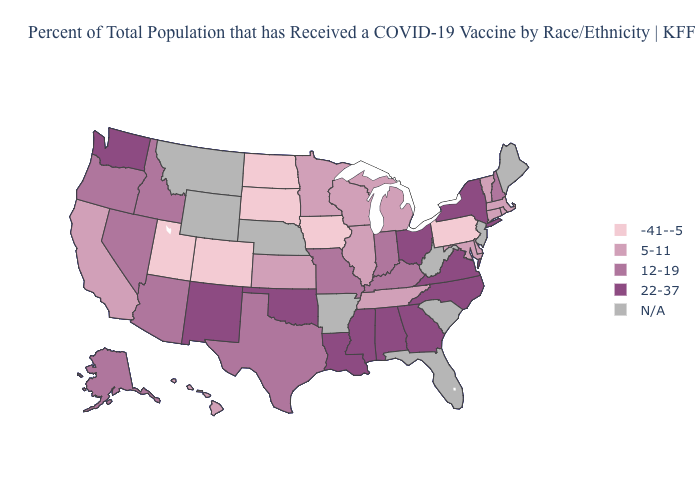Among the states that border New Mexico , which have the lowest value?
Keep it brief. Colorado, Utah. What is the value of Maine?
Answer briefly. N/A. Does New York have the highest value in the Northeast?
Answer briefly. Yes. What is the value of Georgia?
Concise answer only. 22-37. What is the highest value in states that border Indiana?
Answer briefly. 22-37. Which states hav the highest value in the Northeast?
Short answer required. New York. Does Virginia have the highest value in the USA?
Give a very brief answer. Yes. Among the states that border North Carolina , which have the highest value?
Quick response, please. Georgia, Virginia. What is the value of Nevada?
Be succinct. 12-19. What is the value of New Jersey?
Keep it brief. N/A. What is the lowest value in the Northeast?
Quick response, please. -41--5. Name the states that have a value in the range 12-19?
Write a very short answer. Alaska, Arizona, Idaho, Indiana, Kentucky, Missouri, Nevada, New Hampshire, Oregon, Texas. Does Connecticut have the highest value in the USA?
Keep it brief. No. 